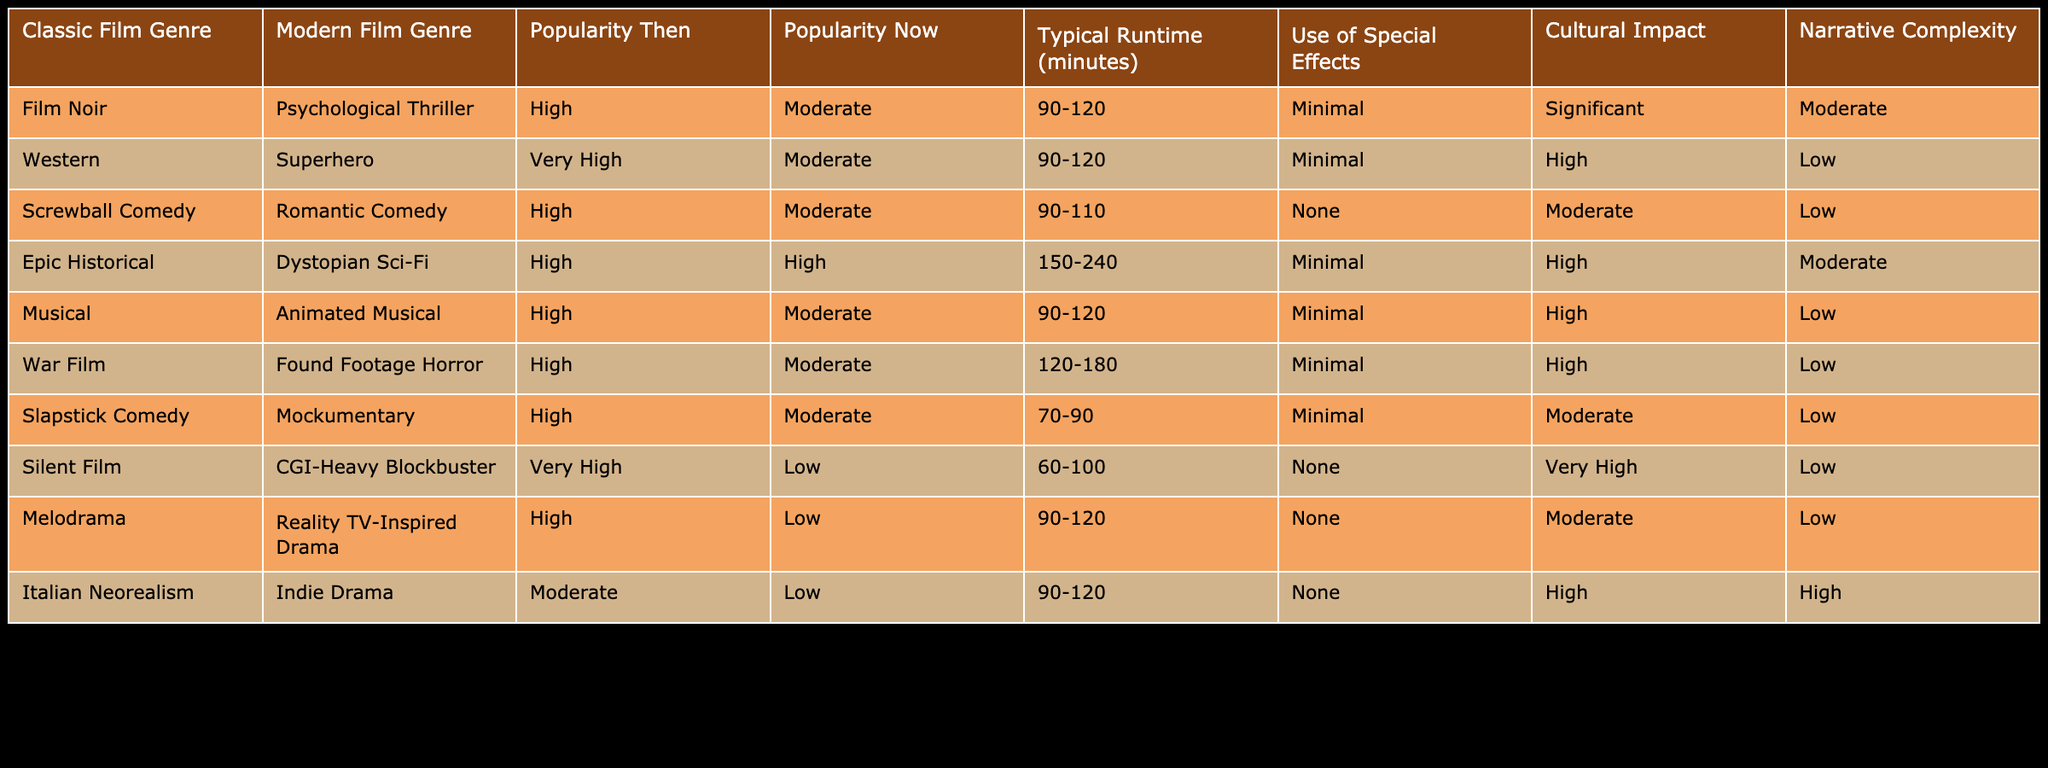What is the typical runtime for classic film genres? The typical runtime for classic film genres varies, but the specified ranges for each are: Film Noir (90-120), Western (90-120), Screwball Comedy (90-110), Epic Historical (150-240), Musical (90-120), War Film (120-180), Slapstick Comedy (70-90), Silent Film (60-100), Melodrama (90-120), Italian Neorealism (90-120). So the typical runtime is generally between 60 and 240 minutes for classic film genres.
Answer: 60-240 minutes Which modern film genre has the highest cultural impact? According to the table, CGI-Heavy Blockbuster from the modern film genres has a very high cultural impact when compared to others which range from low to high.
Answer: CGI-Heavy Blockbuster Is the popularity of the Silent Film genre now low? The table shows that the popularity of the Silent Film genre was very high in the past, but it is currently categorized as low now, reflecting a significant decline.
Answer: Yes What is the average typical runtime of the classic film genres listed? The classic genres have runtimes: (90-120, 90-120, 90-110, 150-240, 90-120, 120-180, 70-90, 60-100, 90-120, 90-120). If we calculate the average of the midpoints, we get: (105 + 105 + 100 + 195 + 105 + 150 + 80 + 80 + 105 + 105) / 10 = 112.5. Therefore, the average is approximately 112.5 minutes.
Answer: 112.5 minutes What is the pattern of special effects use between classic and modern genres? The table indicates that classic films generally use minimal to no special effects, while modern genres typically employ CGI and other extensive effects, particularly the CGI-Heavy Blockbuster. Thus, there is a clear shift from minimal to high use of special effects in modern genres.
Answer: Shift from minimal to high usage Which modern genre has a higher popularity than its classic counterpart? Among the listed pairings, Dystopian Sci-Fi (modern) has a higher popularity than Epic Historical (classic), both currently being high. However, none of the modern genres surpass their classic equivalents significantly in popularity. So, the only notable pair with equal popularity is this one.
Answer: Dystopian Sci-Fi and Epic Historical have equal popularity 